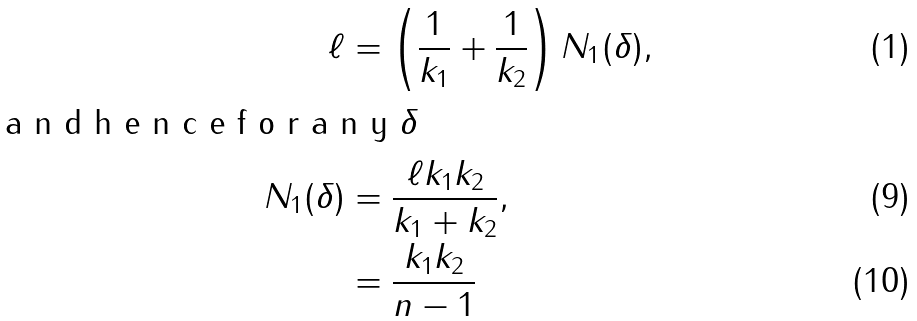<formula> <loc_0><loc_0><loc_500><loc_500>\ell & = \left ( \frac { 1 } { k _ { 1 } } + \frac { 1 } { k _ { 2 } } \right ) N _ { 1 } ( \delta ) , \intertext { a n d h e n c e f o r a n y $ \delta $ } N _ { 1 } ( \delta ) & = \frac { \ell k _ { 1 } k _ { 2 } } { k _ { 1 } + k _ { 2 } } , \\ & = \frac { k _ { 1 } k _ { 2 } } { n - 1 }</formula> 